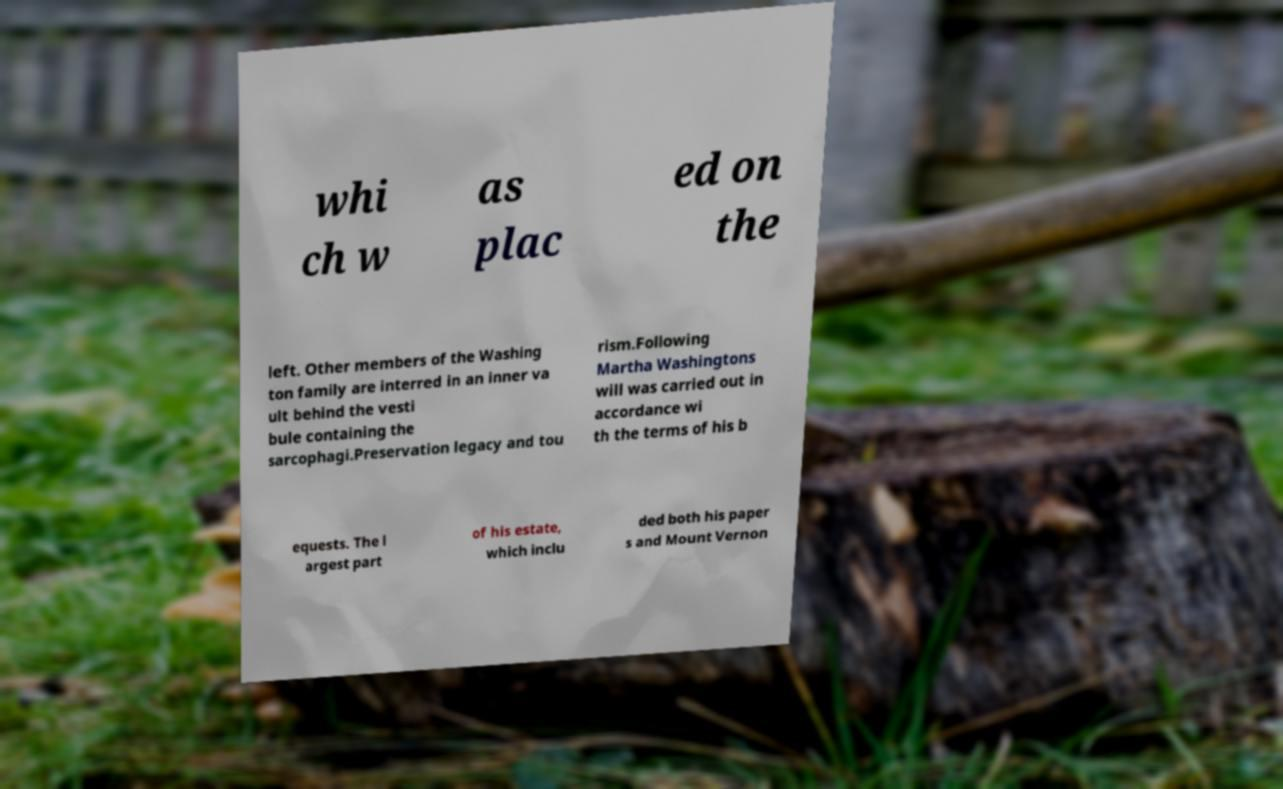Please identify and transcribe the text found in this image. whi ch w as plac ed on the left. Other members of the Washing ton family are interred in an inner va ult behind the vesti bule containing the sarcophagi.Preservation legacy and tou rism.Following Martha Washingtons will was carried out in accordance wi th the terms of his b equests. The l argest part of his estate, which inclu ded both his paper s and Mount Vernon 